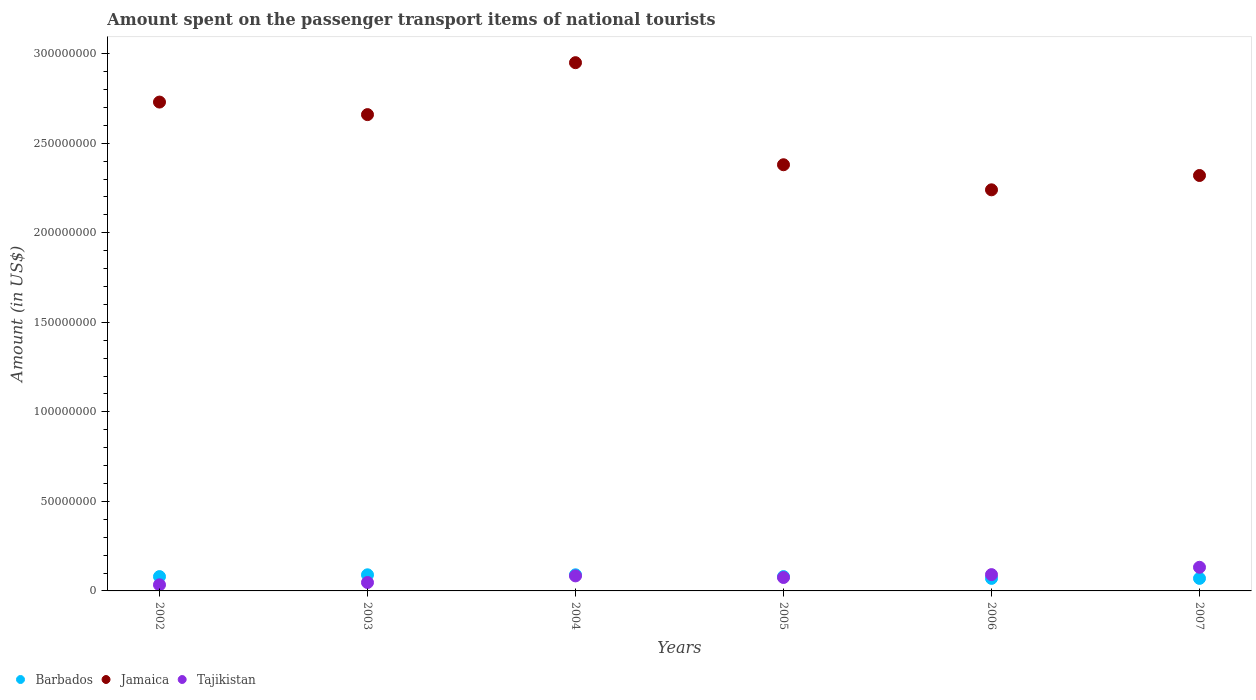How many different coloured dotlines are there?
Your response must be concise. 3. Is the number of dotlines equal to the number of legend labels?
Ensure brevity in your answer.  Yes. Across all years, what is the maximum amount spent on the passenger transport items of national tourists in Tajikistan?
Give a very brief answer. 1.32e+07. Across all years, what is the minimum amount spent on the passenger transport items of national tourists in Jamaica?
Make the answer very short. 2.24e+08. In which year was the amount spent on the passenger transport items of national tourists in Tajikistan maximum?
Your answer should be very brief. 2007. In which year was the amount spent on the passenger transport items of national tourists in Barbados minimum?
Provide a short and direct response. 2006. What is the total amount spent on the passenger transport items of national tourists in Tajikistan in the graph?
Give a very brief answer. 4.63e+07. What is the difference between the amount spent on the passenger transport items of national tourists in Tajikistan in 2002 and that in 2003?
Ensure brevity in your answer.  -1.30e+06. What is the difference between the amount spent on the passenger transport items of national tourists in Jamaica in 2006 and the amount spent on the passenger transport items of national tourists in Tajikistan in 2005?
Offer a very short reply. 2.16e+08. What is the average amount spent on the passenger transport items of national tourists in Tajikistan per year?
Provide a succinct answer. 7.72e+06. In the year 2003, what is the difference between the amount spent on the passenger transport items of national tourists in Jamaica and amount spent on the passenger transport items of national tourists in Tajikistan?
Your answer should be compact. 2.61e+08. What is the ratio of the amount spent on the passenger transport items of national tourists in Barbados in 2004 to that in 2007?
Your answer should be compact. 1.29. Is the amount spent on the passenger transport items of national tourists in Jamaica in 2003 less than that in 2007?
Give a very brief answer. No. Is the difference between the amount spent on the passenger transport items of national tourists in Jamaica in 2004 and 2007 greater than the difference between the amount spent on the passenger transport items of national tourists in Tajikistan in 2004 and 2007?
Your answer should be compact. Yes. What is the difference between the highest and the second highest amount spent on the passenger transport items of national tourists in Tajikistan?
Provide a short and direct response. 4.10e+06. What is the difference between the highest and the lowest amount spent on the passenger transport items of national tourists in Jamaica?
Provide a short and direct response. 7.10e+07. Is the amount spent on the passenger transport items of national tourists in Jamaica strictly greater than the amount spent on the passenger transport items of national tourists in Tajikistan over the years?
Offer a very short reply. Yes. Is the amount spent on the passenger transport items of national tourists in Barbados strictly less than the amount spent on the passenger transport items of national tourists in Jamaica over the years?
Offer a terse response. Yes. How many years are there in the graph?
Offer a very short reply. 6. Are the values on the major ticks of Y-axis written in scientific E-notation?
Your answer should be very brief. No. How are the legend labels stacked?
Offer a terse response. Horizontal. What is the title of the graph?
Keep it short and to the point. Amount spent on the passenger transport items of national tourists. Does "Lebanon" appear as one of the legend labels in the graph?
Offer a terse response. No. What is the label or title of the Y-axis?
Provide a short and direct response. Amount (in US$). What is the Amount (in US$) of Barbados in 2002?
Your response must be concise. 8.00e+06. What is the Amount (in US$) of Jamaica in 2002?
Ensure brevity in your answer.  2.73e+08. What is the Amount (in US$) in Tajikistan in 2002?
Provide a succinct answer. 3.40e+06. What is the Amount (in US$) in Barbados in 2003?
Your answer should be very brief. 9.00e+06. What is the Amount (in US$) of Jamaica in 2003?
Your answer should be compact. 2.66e+08. What is the Amount (in US$) in Tajikistan in 2003?
Make the answer very short. 4.70e+06. What is the Amount (in US$) of Barbados in 2004?
Offer a very short reply. 9.00e+06. What is the Amount (in US$) of Jamaica in 2004?
Make the answer very short. 2.95e+08. What is the Amount (in US$) of Tajikistan in 2004?
Ensure brevity in your answer.  8.40e+06. What is the Amount (in US$) in Jamaica in 2005?
Your answer should be compact. 2.38e+08. What is the Amount (in US$) of Tajikistan in 2005?
Offer a very short reply. 7.50e+06. What is the Amount (in US$) in Barbados in 2006?
Provide a succinct answer. 7.00e+06. What is the Amount (in US$) in Jamaica in 2006?
Your answer should be very brief. 2.24e+08. What is the Amount (in US$) of Tajikistan in 2006?
Provide a short and direct response. 9.10e+06. What is the Amount (in US$) of Jamaica in 2007?
Keep it short and to the point. 2.32e+08. What is the Amount (in US$) in Tajikistan in 2007?
Provide a succinct answer. 1.32e+07. Across all years, what is the maximum Amount (in US$) in Barbados?
Offer a very short reply. 9.00e+06. Across all years, what is the maximum Amount (in US$) in Jamaica?
Your answer should be compact. 2.95e+08. Across all years, what is the maximum Amount (in US$) in Tajikistan?
Your answer should be very brief. 1.32e+07. Across all years, what is the minimum Amount (in US$) of Jamaica?
Your answer should be very brief. 2.24e+08. Across all years, what is the minimum Amount (in US$) in Tajikistan?
Make the answer very short. 3.40e+06. What is the total Amount (in US$) of Barbados in the graph?
Offer a terse response. 4.80e+07. What is the total Amount (in US$) of Jamaica in the graph?
Provide a short and direct response. 1.53e+09. What is the total Amount (in US$) in Tajikistan in the graph?
Provide a short and direct response. 4.63e+07. What is the difference between the Amount (in US$) of Barbados in 2002 and that in 2003?
Keep it short and to the point. -1.00e+06. What is the difference between the Amount (in US$) of Jamaica in 2002 and that in 2003?
Your response must be concise. 7.00e+06. What is the difference between the Amount (in US$) in Tajikistan in 2002 and that in 2003?
Provide a short and direct response. -1.30e+06. What is the difference between the Amount (in US$) in Barbados in 2002 and that in 2004?
Your answer should be compact. -1.00e+06. What is the difference between the Amount (in US$) of Jamaica in 2002 and that in 2004?
Keep it short and to the point. -2.20e+07. What is the difference between the Amount (in US$) of Tajikistan in 2002 and that in 2004?
Your answer should be very brief. -5.00e+06. What is the difference between the Amount (in US$) in Barbados in 2002 and that in 2005?
Provide a short and direct response. 0. What is the difference between the Amount (in US$) of Jamaica in 2002 and that in 2005?
Keep it short and to the point. 3.50e+07. What is the difference between the Amount (in US$) of Tajikistan in 2002 and that in 2005?
Offer a very short reply. -4.10e+06. What is the difference between the Amount (in US$) in Barbados in 2002 and that in 2006?
Offer a very short reply. 1.00e+06. What is the difference between the Amount (in US$) in Jamaica in 2002 and that in 2006?
Your response must be concise. 4.90e+07. What is the difference between the Amount (in US$) in Tajikistan in 2002 and that in 2006?
Your answer should be very brief. -5.70e+06. What is the difference between the Amount (in US$) of Barbados in 2002 and that in 2007?
Keep it short and to the point. 1.00e+06. What is the difference between the Amount (in US$) of Jamaica in 2002 and that in 2007?
Make the answer very short. 4.10e+07. What is the difference between the Amount (in US$) in Tajikistan in 2002 and that in 2007?
Your response must be concise. -9.80e+06. What is the difference between the Amount (in US$) in Barbados in 2003 and that in 2004?
Provide a succinct answer. 0. What is the difference between the Amount (in US$) of Jamaica in 2003 and that in 2004?
Ensure brevity in your answer.  -2.90e+07. What is the difference between the Amount (in US$) of Tajikistan in 2003 and that in 2004?
Provide a short and direct response. -3.70e+06. What is the difference between the Amount (in US$) in Barbados in 2003 and that in 2005?
Provide a succinct answer. 1.00e+06. What is the difference between the Amount (in US$) in Jamaica in 2003 and that in 2005?
Ensure brevity in your answer.  2.80e+07. What is the difference between the Amount (in US$) of Tajikistan in 2003 and that in 2005?
Your answer should be compact. -2.80e+06. What is the difference between the Amount (in US$) of Barbados in 2003 and that in 2006?
Offer a very short reply. 2.00e+06. What is the difference between the Amount (in US$) of Jamaica in 2003 and that in 2006?
Your response must be concise. 4.20e+07. What is the difference between the Amount (in US$) of Tajikistan in 2003 and that in 2006?
Provide a succinct answer. -4.40e+06. What is the difference between the Amount (in US$) of Jamaica in 2003 and that in 2007?
Your answer should be compact. 3.40e+07. What is the difference between the Amount (in US$) in Tajikistan in 2003 and that in 2007?
Provide a succinct answer. -8.50e+06. What is the difference between the Amount (in US$) in Barbados in 2004 and that in 2005?
Offer a very short reply. 1.00e+06. What is the difference between the Amount (in US$) in Jamaica in 2004 and that in 2005?
Offer a very short reply. 5.70e+07. What is the difference between the Amount (in US$) of Tajikistan in 2004 and that in 2005?
Provide a short and direct response. 9.00e+05. What is the difference between the Amount (in US$) in Barbados in 2004 and that in 2006?
Offer a very short reply. 2.00e+06. What is the difference between the Amount (in US$) of Jamaica in 2004 and that in 2006?
Make the answer very short. 7.10e+07. What is the difference between the Amount (in US$) of Tajikistan in 2004 and that in 2006?
Keep it short and to the point. -7.00e+05. What is the difference between the Amount (in US$) in Barbados in 2004 and that in 2007?
Offer a terse response. 2.00e+06. What is the difference between the Amount (in US$) of Jamaica in 2004 and that in 2007?
Keep it short and to the point. 6.30e+07. What is the difference between the Amount (in US$) in Tajikistan in 2004 and that in 2007?
Give a very brief answer. -4.80e+06. What is the difference between the Amount (in US$) in Jamaica in 2005 and that in 2006?
Provide a succinct answer. 1.40e+07. What is the difference between the Amount (in US$) in Tajikistan in 2005 and that in 2006?
Ensure brevity in your answer.  -1.60e+06. What is the difference between the Amount (in US$) in Tajikistan in 2005 and that in 2007?
Give a very brief answer. -5.70e+06. What is the difference between the Amount (in US$) in Jamaica in 2006 and that in 2007?
Offer a very short reply. -8.00e+06. What is the difference between the Amount (in US$) of Tajikistan in 2006 and that in 2007?
Give a very brief answer. -4.10e+06. What is the difference between the Amount (in US$) in Barbados in 2002 and the Amount (in US$) in Jamaica in 2003?
Your response must be concise. -2.58e+08. What is the difference between the Amount (in US$) of Barbados in 2002 and the Amount (in US$) of Tajikistan in 2003?
Your answer should be compact. 3.30e+06. What is the difference between the Amount (in US$) in Jamaica in 2002 and the Amount (in US$) in Tajikistan in 2003?
Offer a terse response. 2.68e+08. What is the difference between the Amount (in US$) in Barbados in 2002 and the Amount (in US$) in Jamaica in 2004?
Give a very brief answer. -2.87e+08. What is the difference between the Amount (in US$) in Barbados in 2002 and the Amount (in US$) in Tajikistan in 2004?
Offer a very short reply. -4.00e+05. What is the difference between the Amount (in US$) of Jamaica in 2002 and the Amount (in US$) of Tajikistan in 2004?
Give a very brief answer. 2.65e+08. What is the difference between the Amount (in US$) of Barbados in 2002 and the Amount (in US$) of Jamaica in 2005?
Give a very brief answer. -2.30e+08. What is the difference between the Amount (in US$) of Jamaica in 2002 and the Amount (in US$) of Tajikistan in 2005?
Your answer should be very brief. 2.66e+08. What is the difference between the Amount (in US$) of Barbados in 2002 and the Amount (in US$) of Jamaica in 2006?
Give a very brief answer. -2.16e+08. What is the difference between the Amount (in US$) of Barbados in 2002 and the Amount (in US$) of Tajikistan in 2006?
Offer a very short reply. -1.10e+06. What is the difference between the Amount (in US$) of Jamaica in 2002 and the Amount (in US$) of Tajikistan in 2006?
Provide a succinct answer. 2.64e+08. What is the difference between the Amount (in US$) in Barbados in 2002 and the Amount (in US$) in Jamaica in 2007?
Ensure brevity in your answer.  -2.24e+08. What is the difference between the Amount (in US$) of Barbados in 2002 and the Amount (in US$) of Tajikistan in 2007?
Provide a short and direct response. -5.20e+06. What is the difference between the Amount (in US$) in Jamaica in 2002 and the Amount (in US$) in Tajikistan in 2007?
Provide a short and direct response. 2.60e+08. What is the difference between the Amount (in US$) of Barbados in 2003 and the Amount (in US$) of Jamaica in 2004?
Make the answer very short. -2.86e+08. What is the difference between the Amount (in US$) in Jamaica in 2003 and the Amount (in US$) in Tajikistan in 2004?
Your answer should be very brief. 2.58e+08. What is the difference between the Amount (in US$) of Barbados in 2003 and the Amount (in US$) of Jamaica in 2005?
Provide a succinct answer. -2.29e+08. What is the difference between the Amount (in US$) in Barbados in 2003 and the Amount (in US$) in Tajikistan in 2005?
Give a very brief answer. 1.50e+06. What is the difference between the Amount (in US$) of Jamaica in 2003 and the Amount (in US$) of Tajikistan in 2005?
Give a very brief answer. 2.58e+08. What is the difference between the Amount (in US$) in Barbados in 2003 and the Amount (in US$) in Jamaica in 2006?
Your answer should be compact. -2.15e+08. What is the difference between the Amount (in US$) of Barbados in 2003 and the Amount (in US$) of Tajikistan in 2006?
Your response must be concise. -1.00e+05. What is the difference between the Amount (in US$) in Jamaica in 2003 and the Amount (in US$) in Tajikistan in 2006?
Ensure brevity in your answer.  2.57e+08. What is the difference between the Amount (in US$) in Barbados in 2003 and the Amount (in US$) in Jamaica in 2007?
Provide a short and direct response. -2.23e+08. What is the difference between the Amount (in US$) of Barbados in 2003 and the Amount (in US$) of Tajikistan in 2007?
Provide a succinct answer. -4.20e+06. What is the difference between the Amount (in US$) of Jamaica in 2003 and the Amount (in US$) of Tajikistan in 2007?
Give a very brief answer. 2.53e+08. What is the difference between the Amount (in US$) in Barbados in 2004 and the Amount (in US$) in Jamaica in 2005?
Give a very brief answer. -2.29e+08. What is the difference between the Amount (in US$) in Barbados in 2004 and the Amount (in US$) in Tajikistan in 2005?
Your answer should be very brief. 1.50e+06. What is the difference between the Amount (in US$) of Jamaica in 2004 and the Amount (in US$) of Tajikistan in 2005?
Your response must be concise. 2.88e+08. What is the difference between the Amount (in US$) of Barbados in 2004 and the Amount (in US$) of Jamaica in 2006?
Provide a short and direct response. -2.15e+08. What is the difference between the Amount (in US$) of Barbados in 2004 and the Amount (in US$) of Tajikistan in 2006?
Ensure brevity in your answer.  -1.00e+05. What is the difference between the Amount (in US$) in Jamaica in 2004 and the Amount (in US$) in Tajikistan in 2006?
Ensure brevity in your answer.  2.86e+08. What is the difference between the Amount (in US$) in Barbados in 2004 and the Amount (in US$) in Jamaica in 2007?
Provide a succinct answer. -2.23e+08. What is the difference between the Amount (in US$) of Barbados in 2004 and the Amount (in US$) of Tajikistan in 2007?
Your answer should be very brief. -4.20e+06. What is the difference between the Amount (in US$) in Jamaica in 2004 and the Amount (in US$) in Tajikistan in 2007?
Provide a short and direct response. 2.82e+08. What is the difference between the Amount (in US$) of Barbados in 2005 and the Amount (in US$) of Jamaica in 2006?
Provide a succinct answer. -2.16e+08. What is the difference between the Amount (in US$) in Barbados in 2005 and the Amount (in US$) in Tajikistan in 2006?
Give a very brief answer. -1.10e+06. What is the difference between the Amount (in US$) in Jamaica in 2005 and the Amount (in US$) in Tajikistan in 2006?
Keep it short and to the point. 2.29e+08. What is the difference between the Amount (in US$) of Barbados in 2005 and the Amount (in US$) of Jamaica in 2007?
Make the answer very short. -2.24e+08. What is the difference between the Amount (in US$) of Barbados in 2005 and the Amount (in US$) of Tajikistan in 2007?
Offer a very short reply. -5.20e+06. What is the difference between the Amount (in US$) in Jamaica in 2005 and the Amount (in US$) in Tajikistan in 2007?
Make the answer very short. 2.25e+08. What is the difference between the Amount (in US$) of Barbados in 2006 and the Amount (in US$) of Jamaica in 2007?
Your answer should be very brief. -2.25e+08. What is the difference between the Amount (in US$) of Barbados in 2006 and the Amount (in US$) of Tajikistan in 2007?
Make the answer very short. -6.20e+06. What is the difference between the Amount (in US$) of Jamaica in 2006 and the Amount (in US$) of Tajikistan in 2007?
Your answer should be very brief. 2.11e+08. What is the average Amount (in US$) of Barbados per year?
Your answer should be very brief. 8.00e+06. What is the average Amount (in US$) in Jamaica per year?
Provide a short and direct response. 2.55e+08. What is the average Amount (in US$) of Tajikistan per year?
Offer a terse response. 7.72e+06. In the year 2002, what is the difference between the Amount (in US$) in Barbados and Amount (in US$) in Jamaica?
Provide a short and direct response. -2.65e+08. In the year 2002, what is the difference between the Amount (in US$) in Barbados and Amount (in US$) in Tajikistan?
Give a very brief answer. 4.60e+06. In the year 2002, what is the difference between the Amount (in US$) in Jamaica and Amount (in US$) in Tajikistan?
Offer a terse response. 2.70e+08. In the year 2003, what is the difference between the Amount (in US$) in Barbados and Amount (in US$) in Jamaica?
Offer a very short reply. -2.57e+08. In the year 2003, what is the difference between the Amount (in US$) in Barbados and Amount (in US$) in Tajikistan?
Give a very brief answer. 4.30e+06. In the year 2003, what is the difference between the Amount (in US$) in Jamaica and Amount (in US$) in Tajikistan?
Your answer should be very brief. 2.61e+08. In the year 2004, what is the difference between the Amount (in US$) of Barbados and Amount (in US$) of Jamaica?
Keep it short and to the point. -2.86e+08. In the year 2004, what is the difference between the Amount (in US$) of Barbados and Amount (in US$) of Tajikistan?
Your answer should be compact. 6.00e+05. In the year 2004, what is the difference between the Amount (in US$) of Jamaica and Amount (in US$) of Tajikistan?
Your response must be concise. 2.87e+08. In the year 2005, what is the difference between the Amount (in US$) of Barbados and Amount (in US$) of Jamaica?
Make the answer very short. -2.30e+08. In the year 2005, what is the difference between the Amount (in US$) in Barbados and Amount (in US$) in Tajikistan?
Your response must be concise. 5.00e+05. In the year 2005, what is the difference between the Amount (in US$) of Jamaica and Amount (in US$) of Tajikistan?
Offer a very short reply. 2.30e+08. In the year 2006, what is the difference between the Amount (in US$) of Barbados and Amount (in US$) of Jamaica?
Offer a terse response. -2.17e+08. In the year 2006, what is the difference between the Amount (in US$) in Barbados and Amount (in US$) in Tajikistan?
Provide a succinct answer. -2.10e+06. In the year 2006, what is the difference between the Amount (in US$) in Jamaica and Amount (in US$) in Tajikistan?
Ensure brevity in your answer.  2.15e+08. In the year 2007, what is the difference between the Amount (in US$) of Barbados and Amount (in US$) of Jamaica?
Make the answer very short. -2.25e+08. In the year 2007, what is the difference between the Amount (in US$) in Barbados and Amount (in US$) in Tajikistan?
Your response must be concise. -6.20e+06. In the year 2007, what is the difference between the Amount (in US$) of Jamaica and Amount (in US$) of Tajikistan?
Offer a very short reply. 2.19e+08. What is the ratio of the Amount (in US$) in Barbados in 2002 to that in 2003?
Make the answer very short. 0.89. What is the ratio of the Amount (in US$) in Jamaica in 2002 to that in 2003?
Your response must be concise. 1.03. What is the ratio of the Amount (in US$) of Tajikistan in 2002 to that in 2003?
Offer a terse response. 0.72. What is the ratio of the Amount (in US$) in Barbados in 2002 to that in 2004?
Your answer should be very brief. 0.89. What is the ratio of the Amount (in US$) in Jamaica in 2002 to that in 2004?
Provide a short and direct response. 0.93. What is the ratio of the Amount (in US$) in Tajikistan in 2002 to that in 2004?
Give a very brief answer. 0.4. What is the ratio of the Amount (in US$) of Barbados in 2002 to that in 2005?
Give a very brief answer. 1. What is the ratio of the Amount (in US$) in Jamaica in 2002 to that in 2005?
Offer a terse response. 1.15. What is the ratio of the Amount (in US$) in Tajikistan in 2002 to that in 2005?
Your response must be concise. 0.45. What is the ratio of the Amount (in US$) in Barbados in 2002 to that in 2006?
Provide a succinct answer. 1.14. What is the ratio of the Amount (in US$) in Jamaica in 2002 to that in 2006?
Your response must be concise. 1.22. What is the ratio of the Amount (in US$) of Tajikistan in 2002 to that in 2006?
Keep it short and to the point. 0.37. What is the ratio of the Amount (in US$) of Barbados in 2002 to that in 2007?
Keep it short and to the point. 1.14. What is the ratio of the Amount (in US$) of Jamaica in 2002 to that in 2007?
Keep it short and to the point. 1.18. What is the ratio of the Amount (in US$) in Tajikistan in 2002 to that in 2007?
Offer a very short reply. 0.26. What is the ratio of the Amount (in US$) of Barbados in 2003 to that in 2004?
Keep it short and to the point. 1. What is the ratio of the Amount (in US$) in Jamaica in 2003 to that in 2004?
Provide a succinct answer. 0.9. What is the ratio of the Amount (in US$) in Tajikistan in 2003 to that in 2004?
Your answer should be very brief. 0.56. What is the ratio of the Amount (in US$) of Jamaica in 2003 to that in 2005?
Give a very brief answer. 1.12. What is the ratio of the Amount (in US$) in Tajikistan in 2003 to that in 2005?
Ensure brevity in your answer.  0.63. What is the ratio of the Amount (in US$) in Jamaica in 2003 to that in 2006?
Give a very brief answer. 1.19. What is the ratio of the Amount (in US$) in Tajikistan in 2003 to that in 2006?
Offer a very short reply. 0.52. What is the ratio of the Amount (in US$) in Jamaica in 2003 to that in 2007?
Give a very brief answer. 1.15. What is the ratio of the Amount (in US$) in Tajikistan in 2003 to that in 2007?
Your response must be concise. 0.36. What is the ratio of the Amount (in US$) of Jamaica in 2004 to that in 2005?
Your answer should be compact. 1.24. What is the ratio of the Amount (in US$) in Tajikistan in 2004 to that in 2005?
Your answer should be very brief. 1.12. What is the ratio of the Amount (in US$) of Barbados in 2004 to that in 2006?
Offer a very short reply. 1.29. What is the ratio of the Amount (in US$) in Jamaica in 2004 to that in 2006?
Provide a short and direct response. 1.32. What is the ratio of the Amount (in US$) in Barbados in 2004 to that in 2007?
Provide a succinct answer. 1.29. What is the ratio of the Amount (in US$) of Jamaica in 2004 to that in 2007?
Keep it short and to the point. 1.27. What is the ratio of the Amount (in US$) in Tajikistan in 2004 to that in 2007?
Your answer should be very brief. 0.64. What is the ratio of the Amount (in US$) in Barbados in 2005 to that in 2006?
Give a very brief answer. 1.14. What is the ratio of the Amount (in US$) in Jamaica in 2005 to that in 2006?
Keep it short and to the point. 1.06. What is the ratio of the Amount (in US$) in Tajikistan in 2005 to that in 2006?
Offer a very short reply. 0.82. What is the ratio of the Amount (in US$) of Jamaica in 2005 to that in 2007?
Your answer should be compact. 1.03. What is the ratio of the Amount (in US$) in Tajikistan in 2005 to that in 2007?
Keep it short and to the point. 0.57. What is the ratio of the Amount (in US$) of Barbados in 2006 to that in 2007?
Give a very brief answer. 1. What is the ratio of the Amount (in US$) in Jamaica in 2006 to that in 2007?
Your response must be concise. 0.97. What is the ratio of the Amount (in US$) in Tajikistan in 2006 to that in 2007?
Your answer should be very brief. 0.69. What is the difference between the highest and the second highest Amount (in US$) in Barbados?
Your answer should be compact. 0. What is the difference between the highest and the second highest Amount (in US$) in Jamaica?
Your response must be concise. 2.20e+07. What is the difference between the highest and the second highest Amount (in US$) of Tajikistan?
Offer a terse response. 4.10e+06. What is the difference between the highest and the lowest Amount (in US$) in Barbados?
Give a very brief answer. 2.00e+06. What is the difference between the highest and the lowest Amount (in US$) in Jamaica?
Offer a very short reply. 7.10e+07. What is the difference between the highest and the lowest Amount (in US$) of Tajikistan?
Your answer should be very brief. 9.80e+06. 